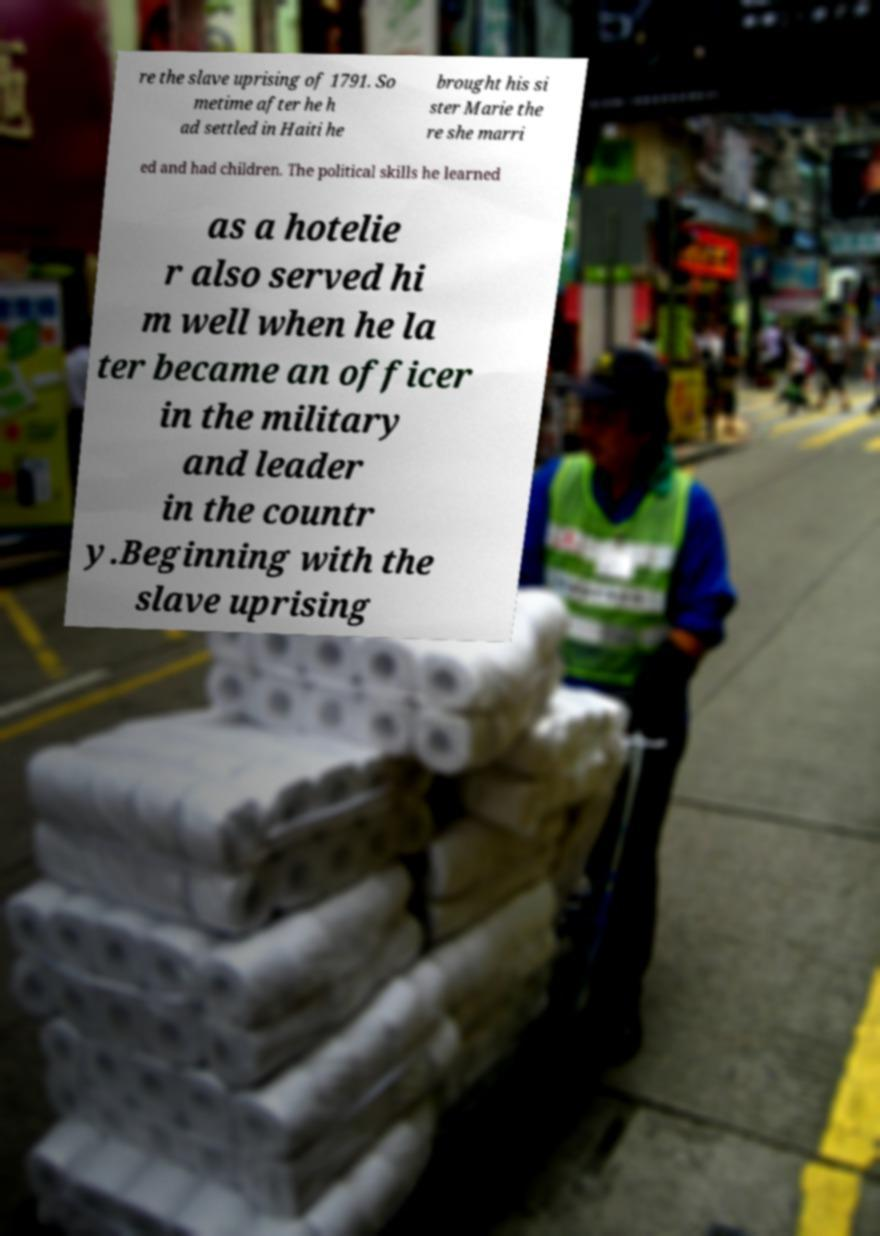Could you assist in decoding the text presented in this image and type it out clearly? re the slave uprising of 1791. So metime after he h ad settled in Haiti he brought his si ster Marie the re she marri ed and had children. The political skills he learned as a hotelie r also served hi m well when he la ter became an officer in the military and leader in the countr y.Beginning with the slave uprising 